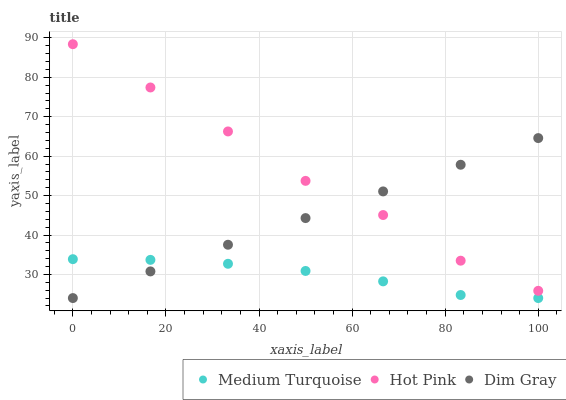Does Medium Turquoise have the minimum area under the curve?
Answer yes or no. Yes. Does Hot Pink have the maximum area under the curve?
Answer yes or no. Yes. Does Hot Pink have the minimum area under the curve?
Answer yes or no. No. Does Medium Turquoise have the maximum area under the curve?
Answer yes or no. No. Is Dim Gray the smoothest?
Answer yes or no. Yes. Is Hot Pink the roughest?
Answer yes or no. Yes. Is Medium Turquoise the smoothest?
Answer yes or no. No. Is Medium Turquoise the roughest?
Answer yes or no. No. Does Dim Gray have the lowest value?
Answer yes or no. Yes. Does Hot Pink have the lowest value?
Answer yes or no. No. Does Hot Pink have the highest value?
Answer yes or no. Yes. Does Medium Turquoise have the highest value?
Answer yes or no. No. Is Medium Turquoise less than Hot Pink?
Answer yes or no. Yes. Is Hot Pink greater than Medium Turquoise?
Answer yes or no. Yes. Does Hot Pink intersect Dim Gray?
Answer yes or no. Yes. Is Hot Pink less than Dim Gray?
Answer yes or no. No. Is Hot Pink greater than Dim Gray?
Answer yes or no. No. Does Medium Turquoise intersect Hot Pink?
Answer yes or no. No. 